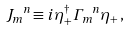Convert formula to latex. <formula><loc_0><loc_0><loc_500><loc_500>{ J _ { m } } ^ { n } \equiv i \, \eta ^ { \dagger } _ { + } { \Gamma _ { m } } ^ { n } \eta _ { + } \, ,</formula> 